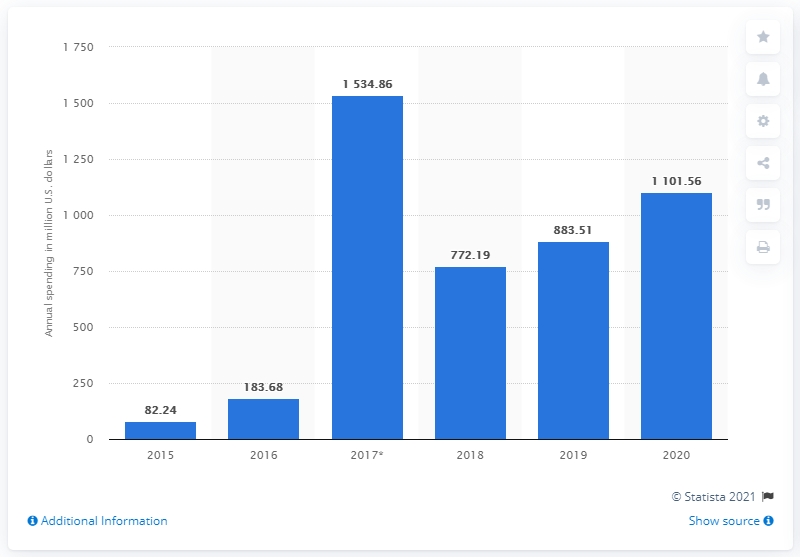Identify some key points in this picture. In the most recent year, Snap spent 1101.56 on research and development. In 2019, Snap spent $883.51 on research and development. 